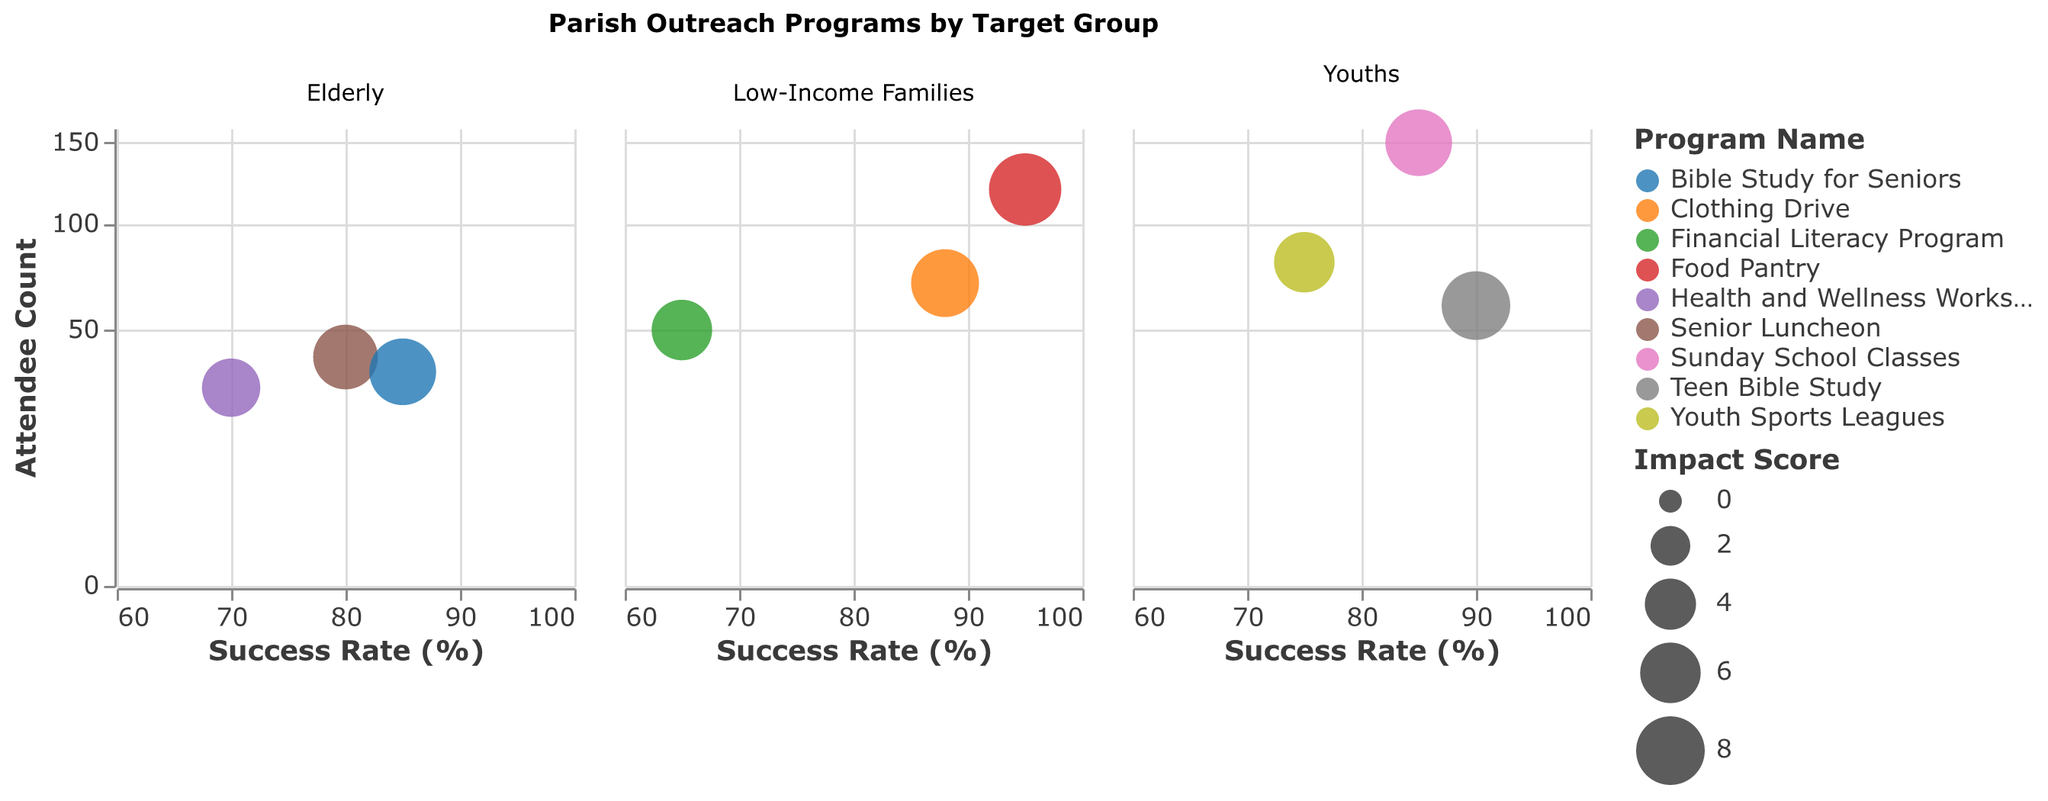What is the title of the figure? The title of the figure is usually displayed at the top. In this case, the title is "Parish Outreach Programs by Target Group".
Answer: Parish Outreach Programs by Target Group What are the axes labels? Axes labels are typically found along the x and y axes. Here, the x-axis is labeled "Success Rate (%)" and the y-axis is labeled "Attendee Count".
Answer: Success Rate (%), Attendee Count Which parish program for 'Low-Income Families' has the highest success rate? To determine this, look at the programs under the 'Low-Income Families' target group and compare their success rates. The highest success rate is 95 for the 'Food Pantry' program.
Answer: Food Pantry Which target group has the program with the highest impact score, and which program is it? Look at each program's impact score across all target groups. 'Low-Income Families' has the highest impact score of 9.0 for the 'Food Pantry' program.
Answer: Low-Income Families, Food Pantry What is the relationship between success rate and attendee count across all target groups? Analyze the plotted points across the x-axis (success rate) and y-axis (attendee count). Generally, there is a positive trend where programs with higher success rates also tend to have higher attendee counts.
Answer: Positive correlation How many programs are there in total for 'Elderly' and which program has the lowest attendee count? Count all unique programs listed under the 'Elderly' group. There are three programs, and the 'Health and Wellness Workshops' has the lowest attendee count with 30 attendees.
Answer: 3, Health and Wellness Workshops Which program for 'Youths' has the highest impact score, and what is its success rate? Look for the 'Youths' target group and find the program with the highest impact score. 'Teen Bible Study' has an impact score of 8.0, and its success rate is 90.
Answer: Teen Bible Study, 90 Compare the success rates of 'Sunday School Classes' for 'Youths' and 'Bible Study for Seniors' for 'Elderly'. Which is higher? 'Sunday School Classes' for 'Youths' has a success rate of 85, while 'Bible Study for Seniors' for 'Elderly' also has a success rate of 85. Both are equal.
Answer: Equal What is the average impact score of the programs for 'Low-Income Families'? Add up the impact scores for all 'Low-Income Families' programs and divide by the number of programs: (9.0 + 6.0 + 7.8) / 3 = 7.6.
Answer: 7.6 